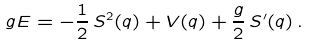<formula> <loc_0><loc_0><loc_500><loc_500>g E = - \frac { 1 } { 2 } \, S ^ { 2 } ( q ) + V ( q ) + \frac { g } { 2 } \, S ^ { \prime } ( q ) \, .</formula> 